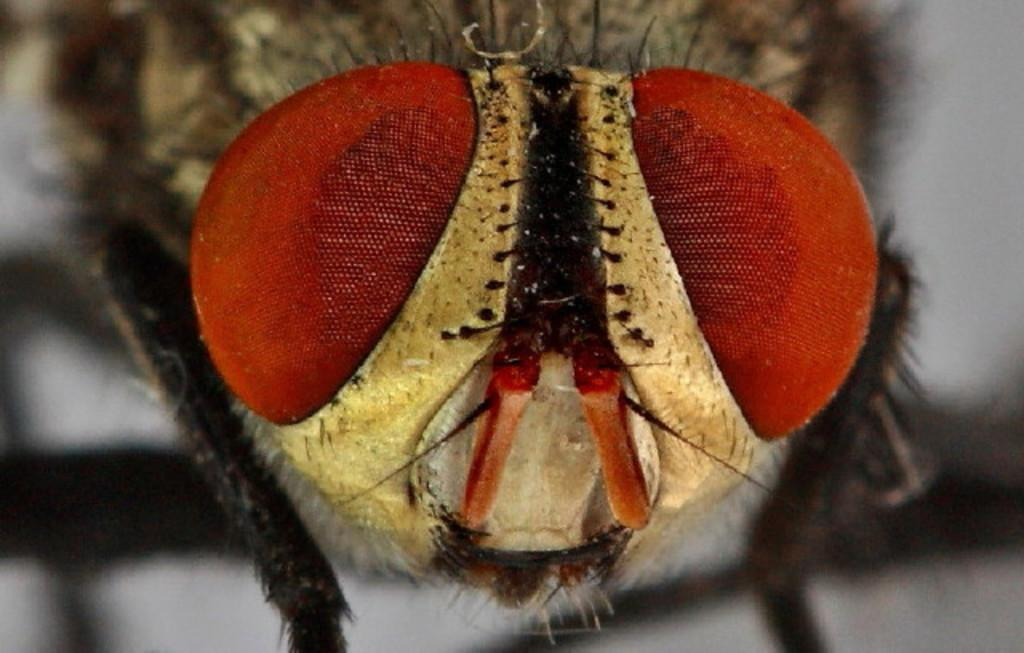What type of insect is present in the image? There is a housefly in the image. How many pictures of a flock of sheep are visible in the image? There are no pictures of a flock of sheep present in the image; it features a housefly. What type of shock can be seen affecting the housefly in the image? There is no shock present in the image; it simply shows a housefly. 